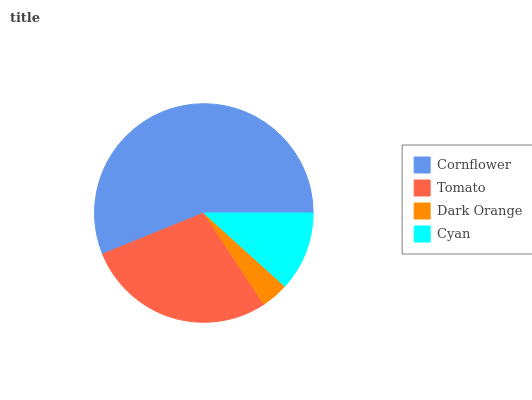Is Dark Orange the minimum?
Answer yes or no. Yes. Is Cornflower the maximum?
Answer yes or no. Yes. Is Tomato the minimum?
Answer yes or no. No. Is Tomato the maximum?
Answer yes or no. No. Is Cornflower greater than Tomato?
Answer yes or no. Yes. Is Tomato less than Cornflower?
Answer yes or no. Yes. Is Tomato greater than Cornflower?
Answer yes or no. No. Is Cornflower less than Tomato?
Answer yes or no. No. Is Tomato the high median?
Answer yes or no. Yes. Is Cyan the low median?
Answer yes or no. Yes. Is Dark Orange the high median?
Answer yes or no. No. Is Tomato the low median?
Answer yes or no. No. 